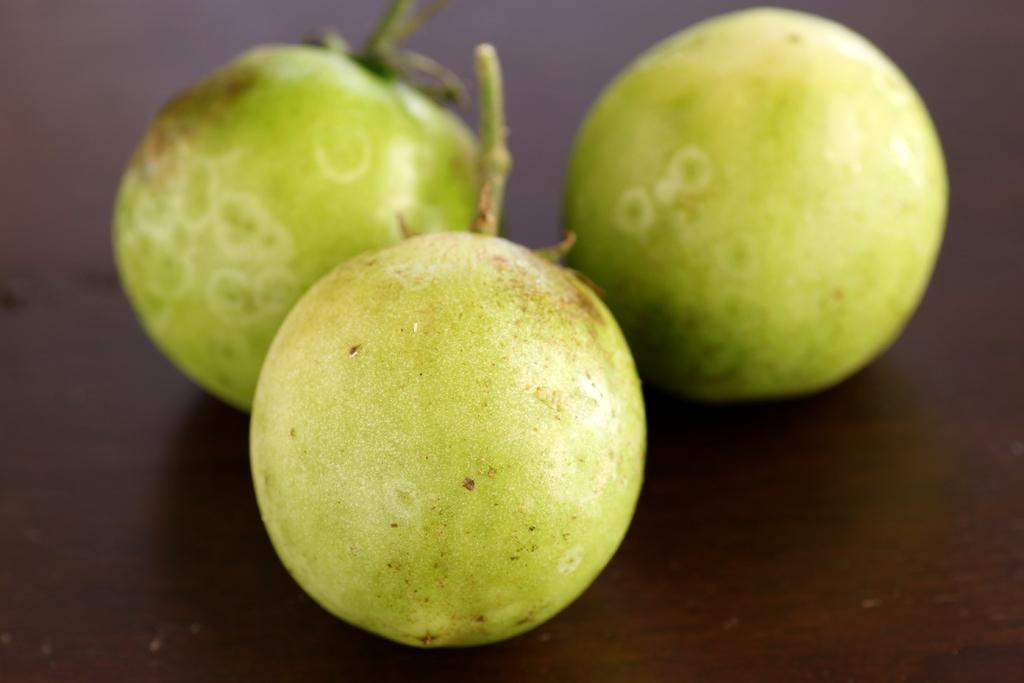How many fruits are visible in the image? There are three fruits in the image. What is the surface on which the fruits are placed? The fruits are on a wooden surface. What type of furniture might the wooden surface be? The wooden surface appears to be a table. Can you describe the process of the geese smashing the fruits in the image? There are no geese or smashing process present in the image; it only features three fruits on a wooden surface. 